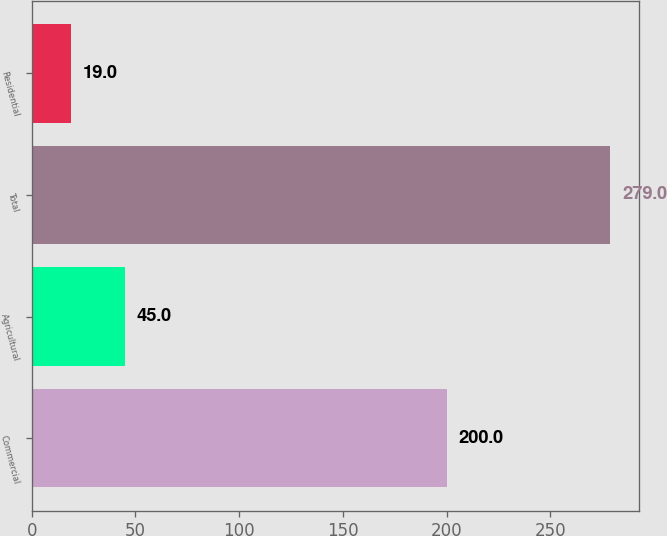Convert chart. <chart><loc_0><loc_0><loc_500><loc_500><bar_chart><fcel>Commercial<fcel>Agricultural<fcel>Total<fcel>Residential<nl><fcel>200<fcel>45<fcel>279<fcel>19<nl></chart> 